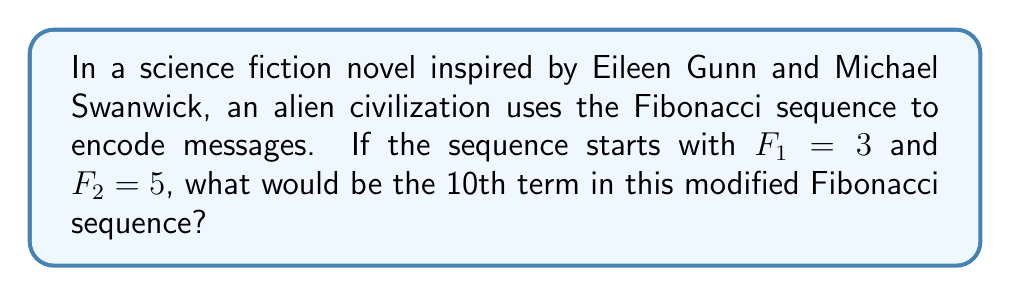What is the answer to this math problem? Let's approach this step-by-step:

1) The standard Fibonacci sequence is defined as:
   $F_n = F_{n-1} + F_{n-2}$ for $n > 2$

2) In this case, we're given modified initial terms:
   $F_1 = 3$ and $F_2 = 5$

3) Let's calculate the subsequent terms:
   $F_3 = F_2 + F_1 = 5 + 3 = 8$
   $F_4 = F_3 + F_2 = 8 + 5 = 13$
   $F_5 = F_4 + F_3 = 13 + 8 = 21$
   $F_6 = F_5 + F_4 = 21 + 13 = 34$
   $F_7 = F_6 + F_5 = 34 + 21 = 55$
   $F_8 = F_7 + F_6 = 55 + 34 = 89$
   $F_9 = F_8 + F_7 = 89 + 55 = 144$
   $F_{10} = F_9 + F_8 = 144 + 89 = 233$

4) Therefore, the 10th term in this modified Fibonacci sequence is 233.

Note: This sequence maintains the Fibonacci property of each term being the sum of the two preceding ones, but with different initial values. This could represent how alien mathematics might be similar to ours in structure, but with different starting points, a common theme in science fiction.
Answer: 233 